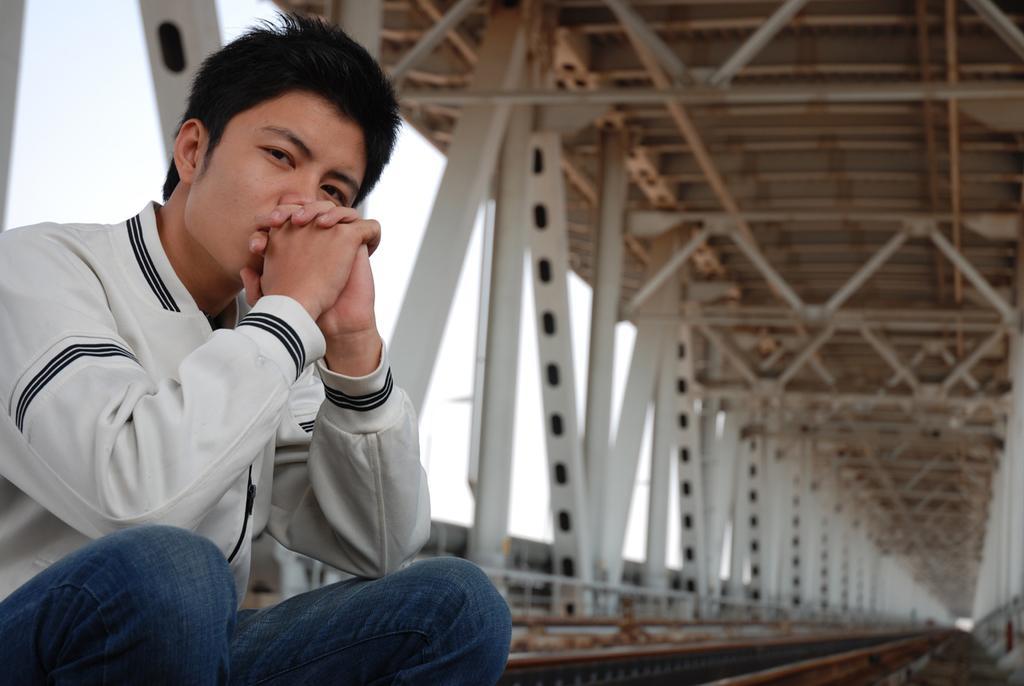In one or two sentences, can you explain what this image depicts? In this image, we can see a person who is wearing white shirt and blue jeans is sitting on a bridge. 